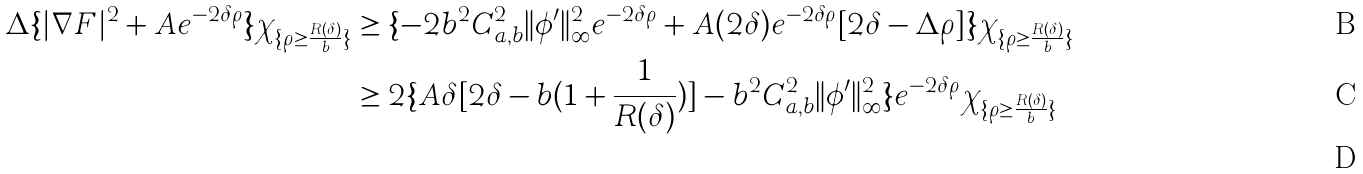<formula> <loc_0><loc_0><loc_500><loc_500>\Delta \{ | \nabla F | ^ { 2 } + A e ^ { - 2 \delta \rho } \} \chi _ { \{ \rho \geq \frac { R ( \delta ) } { b } \} } & \geq \{ - 2 b ^ { 2 } C _ { a , b } ^ { 2 } \| \phi ^ { \prime } \| _ { \infty } ^ { 2 } e ^ { - 2 \delta \rho } + A ( 2 \delta ) e ^ { - 2 \delta \rho } [ 2 \delta - \Delta \rho ] \} \chi _ { \{ \rho \geq \frac { R ( \delta ) } { b } \} } \\ & \geq 2 \{ A \delta [ 2 \delta - b ( 1 + \frac { 1 } { R ( \delta ) } ) ] - b ^ { 2 } C _ { a , b } ^ { 2 } \| \phi ^ { \prime } \| _ { \infty } ^ { 2 } \} e ^ { - 2 \delta \rho } \chi _ { \{ \rho \geq \frac { R ( \delta ) } { b } \} } \\</formula> 